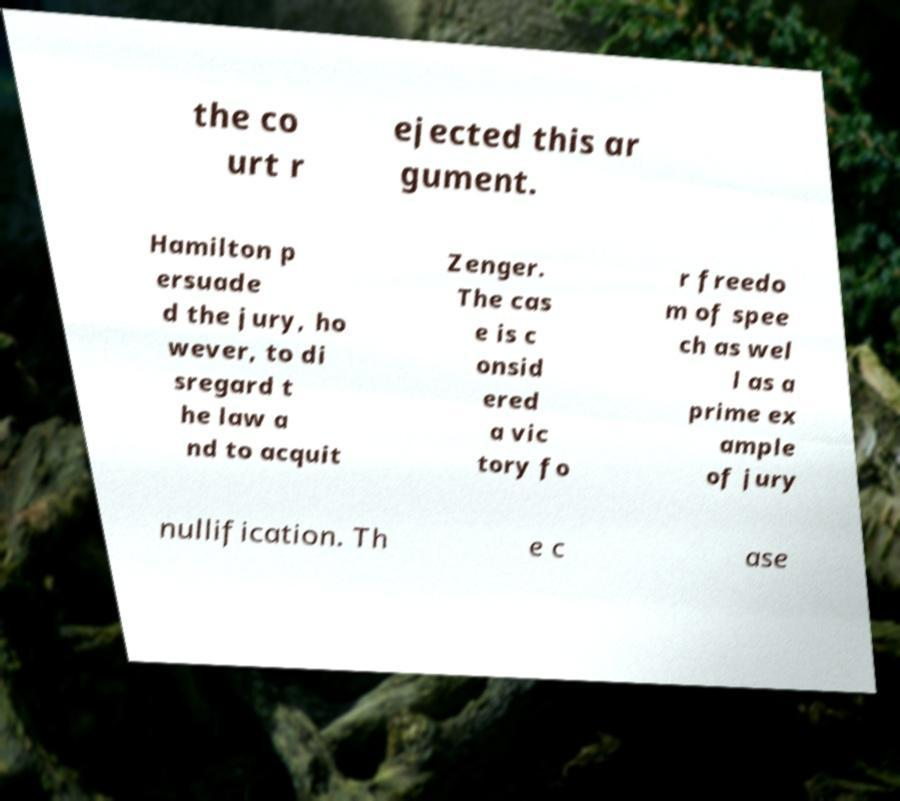For documentation purposes, I need the text within this image transcribed. Could you provide that? the co urt r ejected this ar gument. Hamilton p ersuade d the jury, ho wever, to di sregard t he law a nd to acquit Zenger. The cas e is c onsid ered a vic tory fo r freedo m of spee ch as wel l as a prime ex ample of jury nullification. Th e c ase 